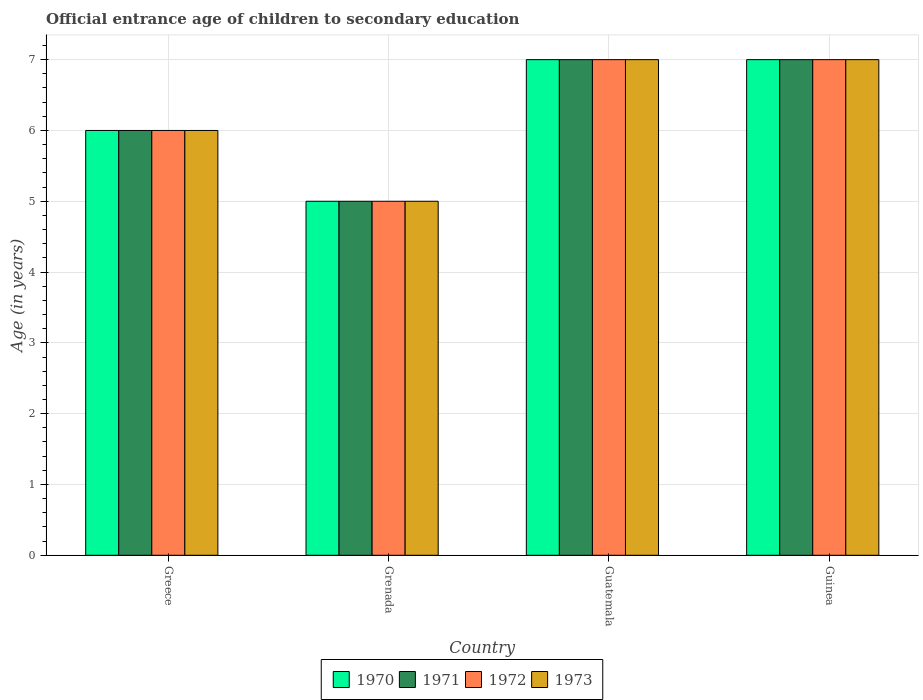How many different coloured bars are there?
Offer a terse response. 4. How many groups of bars are there?
Give a very brief answer. 4. Are the number of bars per tick equal to the number of legend labels?
Offer a terse response. Yes. Are the number of bars on each tick of the X-axis equal?
Give a very brief answer. Yes. How many bars are there on the 4th tick from the right?
Provide a succinct answer. 4. What is the label of the 2nd group of bars from the left?
Offer a very short reply. Grenada. In how many cases, is the number of bars for a given country not equal to the number of legend labels?
Provide a succinct answer. 0. Across all countries, what is the minimum secondary school starting age of children in 1972?
Your answer should be very brief. 5. In which country was the secondary school starting age of children in 1970 maximum?
Offer a terse response. Guatemala. In which country was the secondary school starting age of children in 1970 minimum?
Give a very brief answer. Grenada. What is the average secondary school starting age of children in 1970 per country?
Make the answer very short. 6.25. In how many countries, is the secondary school starting age of children in 1971 greater than 2.8 years?
Ensure brevity in your answer.  4. What is the ratio of the secondary school starting age of children in 1973 in Grenada to that in Guinea?
Make the answer very short. 0.71. What is the difference between the highest and the second highest secondary school starting age of children in 1970?
Ensure brevity in your answer.  -1. What is the difference between the highest and the lowest secondary school starting age of children in 1973?
Provide a short and direct response. 2. Is it the case that in every country, the sum of the secondary school starting age of children in 1970 and secondary school starting age of children in 1973 is greater than the sum of secondary school starting age of children in 1971 and secondary school starting age of children in 1972?
Ensure brevity in your answer.  No. What does the 2nd bar from the left in Guinea represents?
Your answer should be very brief. 1971. What does the 2nd bar from the right in Greece represents?
Make the answer very short. 1972. Is it the case that in every country, the sum of the secondary school starting age of children in 1970 and secondary school starting age of children in 1973 is greater than the secondary school starting age of children in 1972?
Keep it short and to the point. Yes. What is the difference between two consecutive major ticks on the Y-axis?
Provide a short and direct response. 1. Are the values on the major ticks of Y-axis written in scientific E-notation?
Your response must be concise. No. Does the graph contain any zero values?
Provide a short and direct response. No. Where does the legend appear in the graph?
Ensure brevity in your answer.  Bottom center. How many legend labels are there?
Offer a very short reply. 4. What is the title of the graph?
Ensure brevity in your answer.  Official entrance age of children to secondary education. What is the label or title of the X-axis?
Make the answer very short. Country. What is the label or title of the Y-axis?
Provide a succinct answer. Age (in years). What is the Age (in years) in 1970 in Greece?
Keep it short and to the point. 6. What is the Age (in years) of 1972 in Greece?
Give a very brief answer. 6. What is the Age (in years) of 1973 in Greece?
Your answer should be very brief. 6. What is the Age (in years) of 1970 in Grenada?
Offer a very short reply. 5. Across all countries, what is the minimum Age (in years) in 1971?
Provide a succinct answer. 5. Across all countries, what is the minimum Age (in years) in 1972?
Keep it short and to the point. 5. What is the total Age (in years) of 1971 in the graph?
Your response must be concise. 25. What is the total Age (in years) of 1973 in the graph?
Offer a very short reply. 25. What is the difference between the Age (in years) of 1970 in Greece and that in Grenada?
Provide a short and direct response. 1. What is the difference between the Age (in years) of 1971 in Greece and that in Grenada?
Offer a very short reply. 1. What is the difference between the Age (in years) in 1973 in Greece and that in Grenada?
Provide a succinct answer. 1. What is the difference between the Age (in years) of 1971 in Greece and that in Guatemala?
Offer a terse response. -1. What is the difference between the Age (in years) of 1972 in Greece and that in Guatemala?
Make the answer very short. -1. What is the difference between the Age (in years) of 1973 in Greece and that in Guinea?
Your answer should be compact. -1. What is the difference between the Age (in years) of 1970 in Grenada and that in Guinea?
Provide a succinct answer. -2. What is the difference between the Age (in years) of 1971 in Grenada and that in Guinea?
Your response must be concise. -2. What is the difference between the Age (in years) of 1972 in Grenada and that in Guinea?
Make the answer very short. -2. What is the difference between the Age (in years) of 1973 in Grenada and that in Guinea?
Offer a very short reply. -2. What is the difference between the Age (in years) of 1970 in Guatemala and that in Guinea?
Offer a very short reply. 0. What is the difference between the Age (in years) in 1972 in Guatemala and that in Guinea?
Offer a very short reply. 0. What is the difference between the Age (in years) in 1970 in Greece and the Age (in years) in 1972 in Grenada?
Your answer should be compact. 1. What is the difference between the Age (in years) of 1971 in Greece and the Age (in years) of 1973 in Grenada?
Keep it short and to the point. 1. What is the difference between the Age (in years) of 1972 in Greece and the Age (in years) of 1973 in Grenada?
Give a very brief answer. 1. What is the difference between the Age (in years) in 1970 in Greece and the Age (in years) in 1971 in Guatemala?
Provide a succinct answer. -1. What is the difference between the Age (in years) in 1970 in Greece and the Age (in years) in 1973 in Guinea?
Ensure brevity in your answer.  -1. What is the difference between the Age (in years) of 1971 in Greece and the Age (in years) of 1973 in Guinea?
Keep it short and to the point. -1. What is the difference between the Age (in years) of 1972 in Greece and the Age (in years) of 1973 in Guinea?
Ensure brevity in your answer.  -1. What is the difference between the Age (in years) in 1970 in Grenada and the Age (in years) in 1973 in Guatemala?
Your answer should be very brief. -2. What is the difference between the Age (in years) in 1971 in Grenada and the Age (in years) in 1972 in Guatemala?
Give a very brief answer. -2. What is the difference between the Age (in years) in 1970 in Grenada and the Age (in years) in 1972 in Guinea?
Ensure brevity in your answer.  -2. What is the difference between the Age (in years) of 1970 in Grenada and the Age (in years) of 1973 in Guinea?
Keep it short and to the point. -2. What is the difference between the Age (in years) of 1971 in Grenada and the Age (in years) of 1972 in Guinea?
Give a very brief answer. -2. What is the difference between the Age (in years) in 1972 in Grenada and the Age (in years) in 1973 in Guinea?
Give a very brief answer. -2. What is the difference between the Age (in years) of 1970 in Guatemala and the Age (in years) of 1971 in Guinea?
Provide a succinct answer. 0. What is the difference between the Age (in years) of 1970 in Guatemala and the Age (in years) of 1972 in Guinea?
Provide a succinct answer. 0. What is the difference between the Age (in years) of 1971 in Guatemala and the Age (in years) of 1973 in Guinea?
Give a very brief answer. 0. What is the average Age (in years) in 1970 per country?
Give a very brief answer. 6.25. What is the average Age (in years) of 1971 per country?
Your answer should be compact. 6.25. What is the average Age (in years) in 1972 per country?
Offer a terse response. 6.25. What is the average Age (in years) of 1973 per country?
Keep it short and to the point. 6.25. What is the difference between the Age (in years) of 1970 and Age (in years) of 1971 in Greece?
Your answer should be very brief. 0. What is the difference between the Age (in years) in 1970 and Age (in years) in 1971 in Grenada?
Offer a very short reply. 0. What is the difference between the Age (in years) of 1970 and Age (in years) of 1973 in Grenada?
Offer a terse response. 0. What is the difference between the Age (in years) of 1971 and Age (in years) of 1972 in Grenada?
Provide a succinct answer. 0. What is the difference between the Age (in years) in 1971 and Age (in years) in 1973 in Grenada?
Make the answer very short. 0. What is the difference between the Age (in years) in 1971 and Age (in years) in 1972 in Guatemala?
Your answer should be very brief. 0. What is the difference between the Age (in years) in 1971 and Age (in years) in 1973 in Guatemala?
Keep it short and to the point. 0. What is the difference between the Age (in years) in 1972 and Age (in years) in 1973 in Guatemala?
Your answer should be compact. 0. What is the difference between the Age (in years) of 1970 and Age (in years) of 1972 in Guinea?
Give a very brief answer. 0. What is the difference between the Age (in years) of 1970 and Age (in years) of 1973 in Guinea?
Your answer should be very brief. 0. What is the ratio of the Age (in years) in 1970 in Greece to that in Grenada?
Make the answer very short. 1.2. What is the ratio of the Age (in years) of 1971 in Greece to that in Grenada?
Provide a succinct answer. 1.2. What is the ratio of the Age (in years) of 1973 in Greece to that in Grenada?
Offer a very short reply. 1.2. What is the ratio of the Age (in years) of 1972 in Greece to that in Guatemala?
Offer a terse response. 0.86. What is the ratio of the Age (in years) of 1973 in Greece to that in Guatemala?
Offer a terse response. 0.86. What is the ratio of the Age (in years) of 1971 in Greece to that in Guinea?
Give a very brief answer. 0.86. What is the ratio of the Age (in years) of 1972 in Greece to that in Guinea?
Give a very brief answer. 0.86. What is the ratio of the Age (in years) of 1972 in Grenada to that in Guatemala?
Make the answer very short. 0.71. What is the ratio of the Age (in years) in 1971 in Grenada to that in Guinea?
Offer a very short reply. 0.71. What is the ratio of the Age (in years) of 1971 in Guatemala to that in Guinea?
Give a very brief answer. 1. What is the difference between the highest and the second highest Age (in years) in 1972?
Offer a very short reply. 0. What is the difference between the highest and the second highest Age (in years) in 1973?
Your response must be concise. 0. What is the difference between the highest and the lowest Age (in years) in 1972?
Ensure brevity in your answer.  2. 